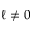Convert formula to latex. <formula><loc_0><loc_0><loc_500><loc_500>\ell \neq 0</formula> 